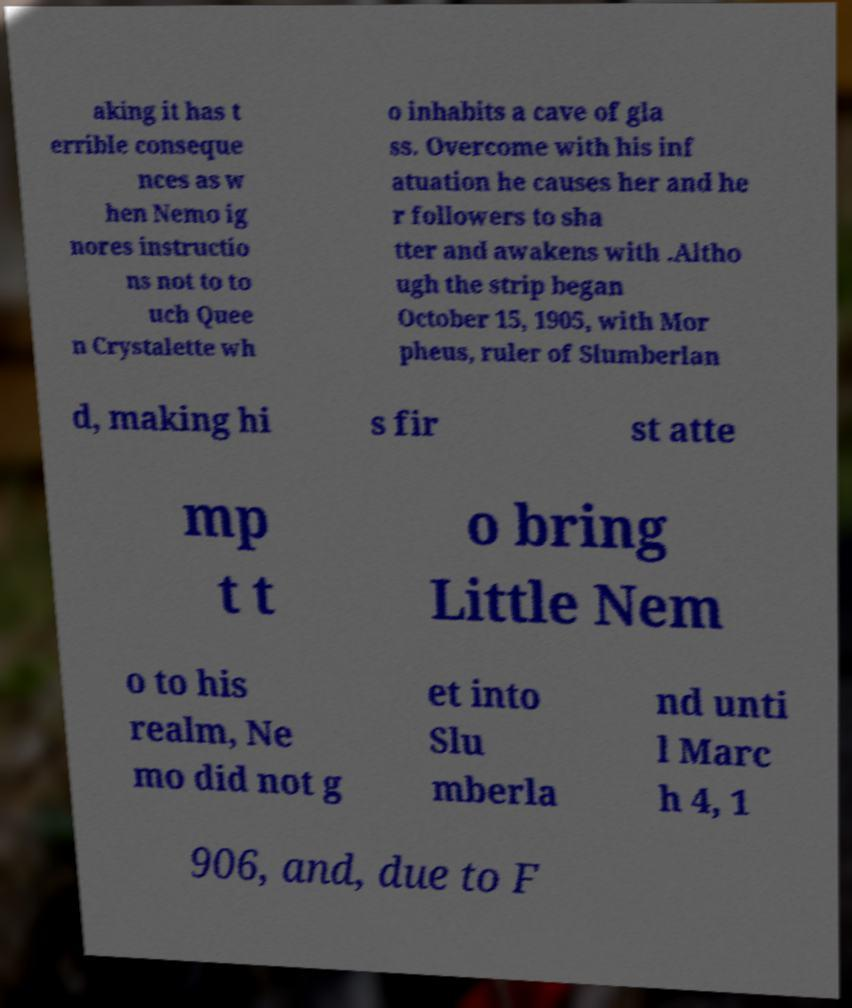I need the written content from this picture converted into text. Can you do that? aking it has t errible conseque nces as w hen Nemo ig nores instructio ns not to to uch Quee n Crystalette wh o inhabits a cave of gla ss. Overcome with his inf atuation he causes her and he r followers to sha tter and awakens with .Altho ugh the strip began October 15, 1905, with Mor pheus, ruler of Slumberlan d, making hi s fir st atte mp t t o bring Little Nem o to his realm, Ne mo did not g et into Slu mberla nd unti l Marc h 4, 1 906, and, due to F 